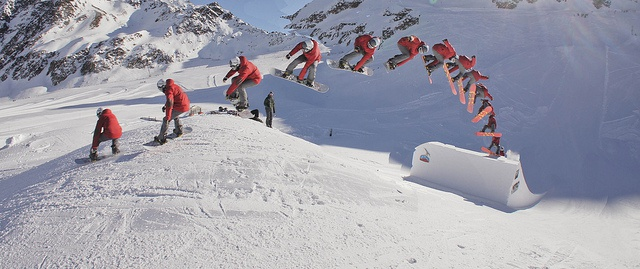Describe the objects in this image and their specific colors. I can see people in gray, maroon, salmon, and black tones, people in gray, maroon, black, and salmon tones, people in gray, lightgray, and darkgray tones, people in gray, black, maroon, and red tones, and people in gray, black, maroon, and darkgray tones in this image. 